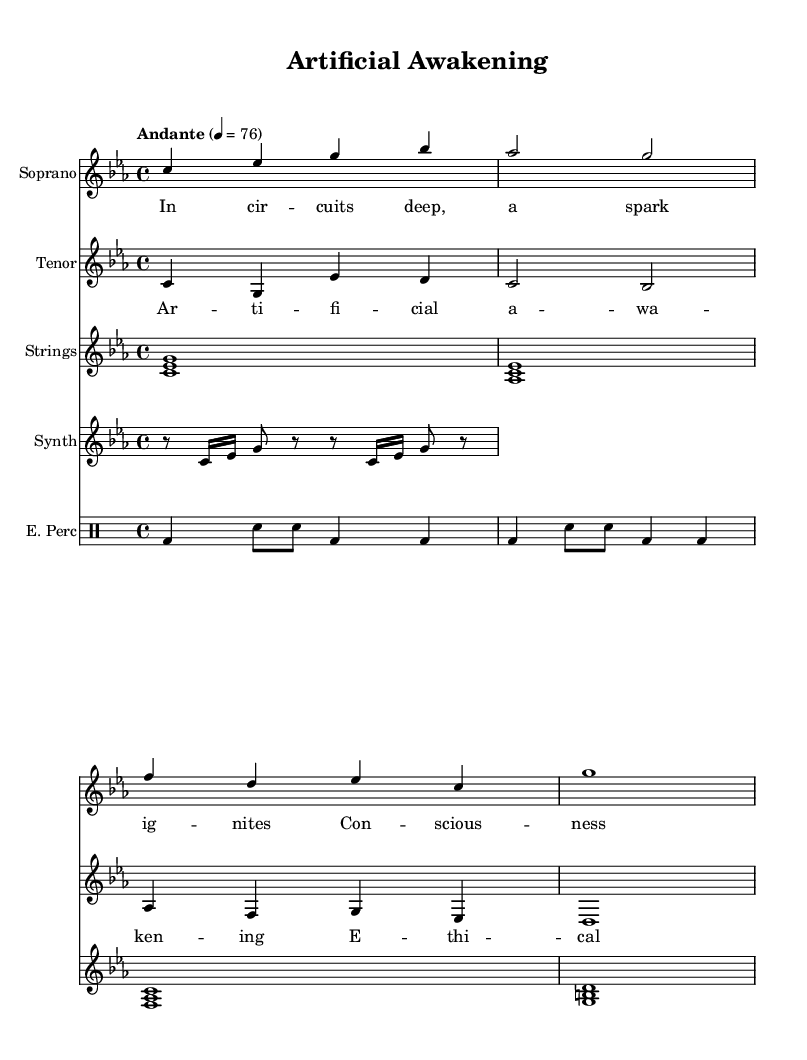What is the key signature of this music? The key signature is indicated by the key signature at the beginning of the score, which shows three flats. This corresponds to C minor.
Answer: C minor What is the time signature of this music? The time signature is found at the beginning of the score, displayed as the fraction 4/4. This means there are four beats in each measure with a quarter note receiving one beat.
Answer: 4/4 What is the tempo marking of this piece? The tempo marking appears at the beginning of the score, stating "Andante" which indicates a moderate pace of walking speed, and is accompanied by a metronome marking of 76 beats per minute.
Answer: Andante 76 What instruments are included in this opera? The instruments are listed in their respective staff headings. They include Soprano, Tenor, Strings, Synth, and Electronic Percussion.
Answer: Soprano, Tenor, Strings, Synth, Electronic Percussion How many measures are there in the soprano line? By counting the groups of notes in the soprano line, it is apparent that there are four distinct measures. This is determined by the vertical lines separating each measure in the staff.
Answer: 4 What theme is suggested by the lyrics "Artificial Awakening"? The lyrics suggest a theme of the emergence of consciousness in artificial beings, indicating a focus on the ethical considerations of AI in society. This conclusion is drawn from the themes discussed in the verse and chorus, which mention awakening and ethical dilemmas.
Answer: Ethical dilemmas in AI What is the role of the electronic percussion in this opera? The role of the electronic percussion is to provide a modern, rhythmic foundation that complements the melodic lines of the opera. By examining the rhythmic patterns and the use of electronic sounds, one can identify its purpose in creating a futuristic soundscape.
Answer: Modern rhythmic foundation 